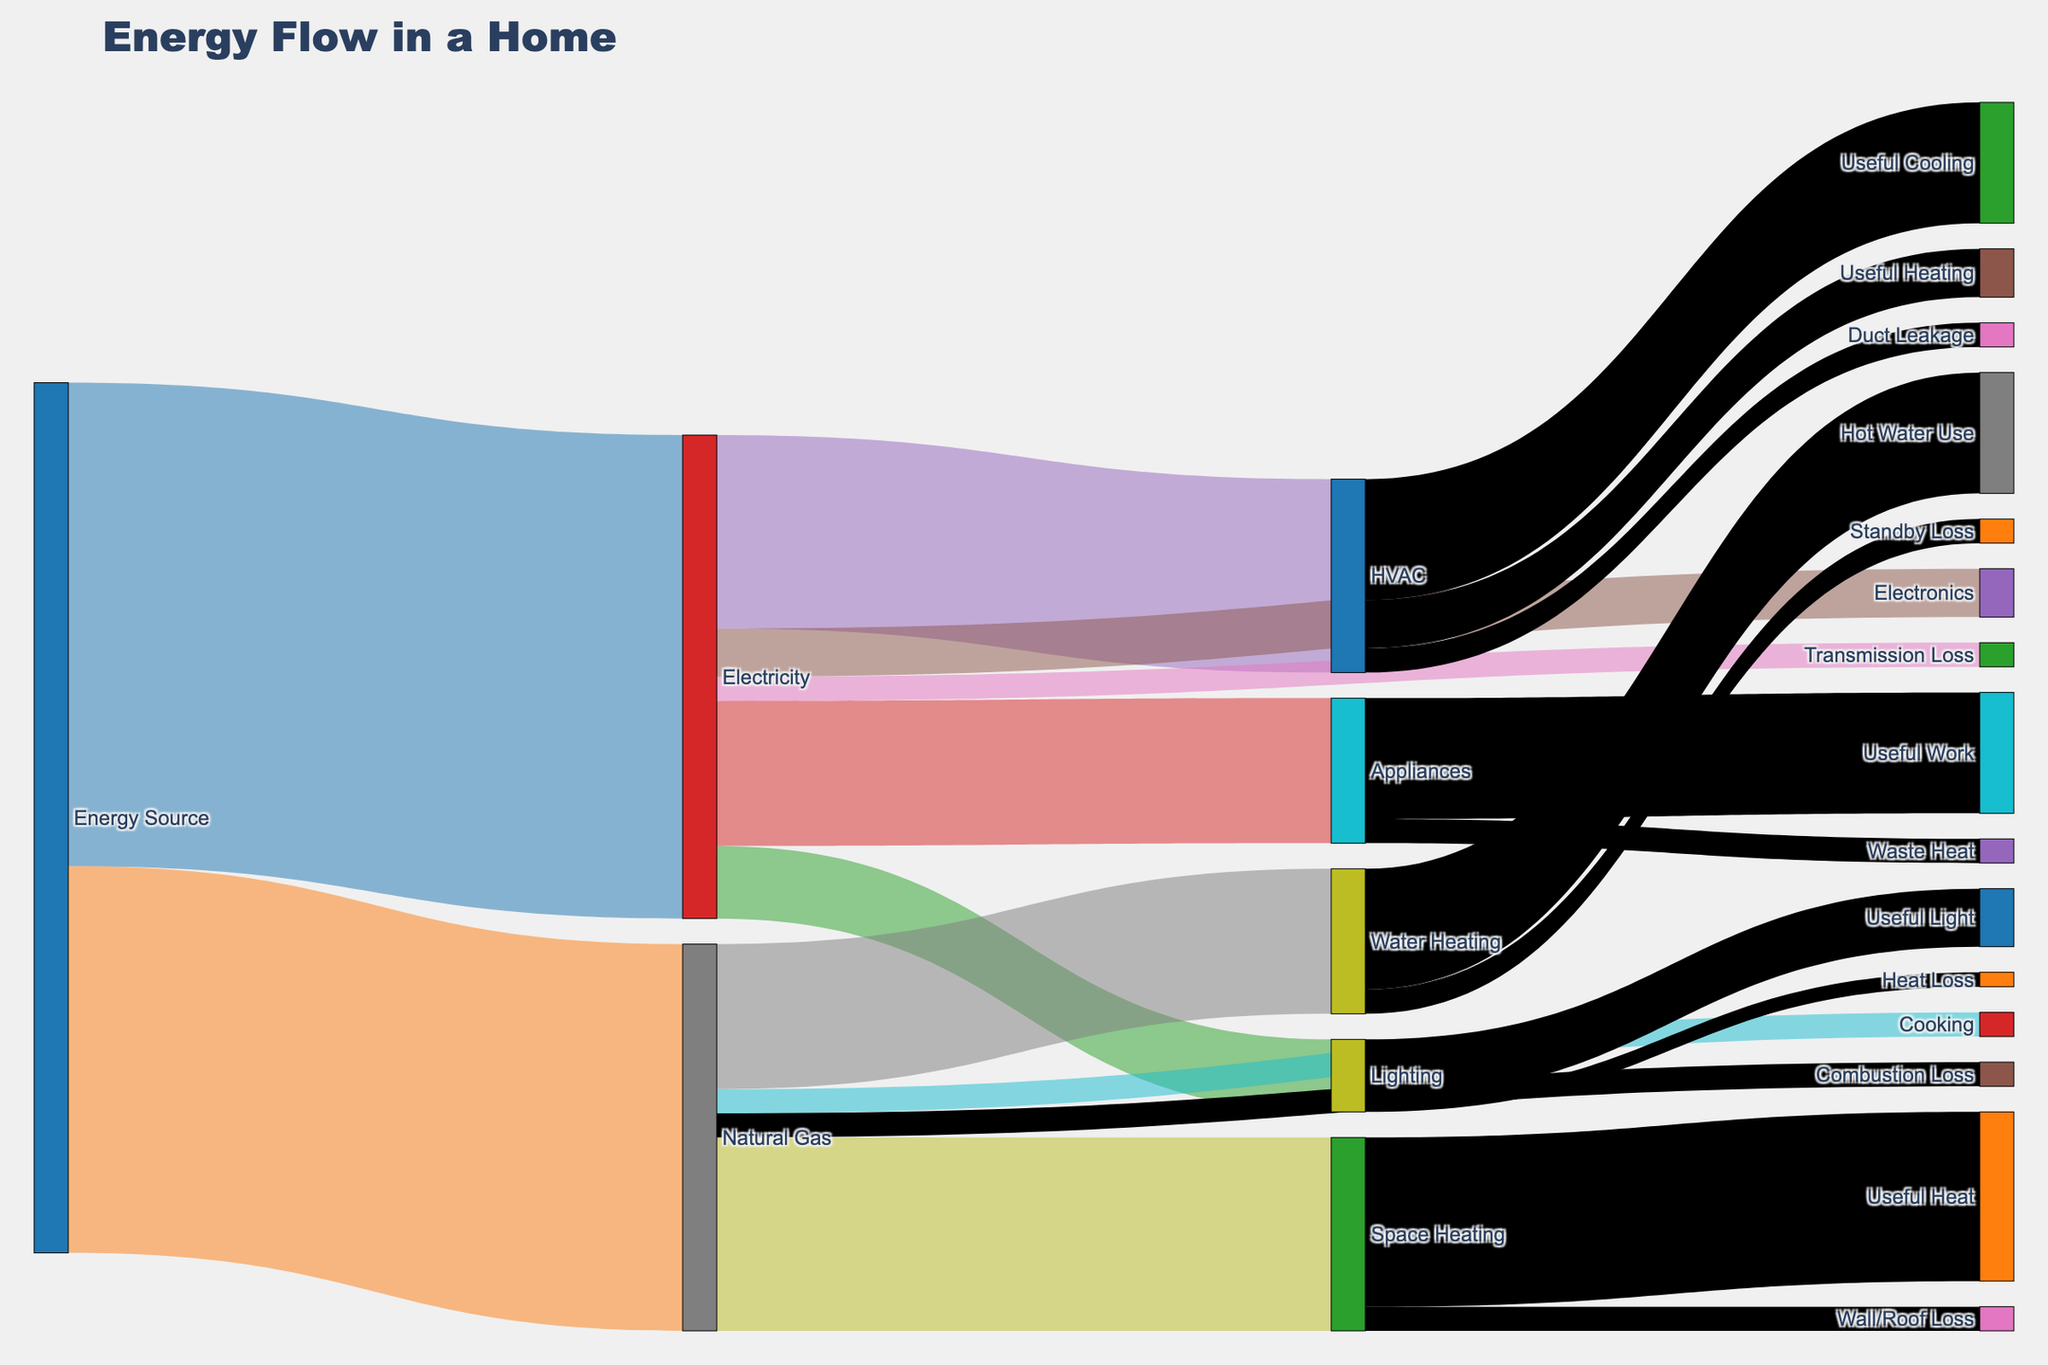What is the main source of energy in the home? The main source of energy can be identified by looking at the values associated with each initial energy source. Electricity has a value of 100, whereas Natural Gas has a value of 80, making Electricity the main source of energy.
Answer: Electricity What is the total amount of energy used for HVAC from both electricity and gas? To find the total amount of energy used for HVAC, we need to add the values from both electricity and natural gas related to HVAC. Electricity provides 40 units of energy to HVAC and Natural Gas is not directly used for HVAC. So, the total is 40.
Answer: 40 How much energy is lost during electricity transmission? The energy lost during electricity transmission is shown as "Transmission Loss" in the diagram. The value associated with this loss is 5.
Answer: 5 Which appliance or usage category receives more energy from electricity, HVAC or Appliances? By comparing the values for HVAC (40) and Appliances (30) in the diagram, it is clear that HVAC receives more energy from electricity than Appliances.
Answer: HVAC How much energy is wasted in the HVAC system through duct leakage? The energy wasted in the HVAC system through duct leakage can be directly seen from the diagram, and it is represented by a value of 5.
Answer: 5 What is the sum of energy used for lighting and electronics from electricity? To determine the total energy used for lighting and electronics, sum the values associated with each from electricity: Lighting (15) and Electronics (10). The sum is 15 + 10 = 25.
Answer: 25 How much energy from natural gas is used for useful heating in space heating? The useful energy for space heating from natural gas is shown in the diagram as "Useful Heat" under Space Heating, with a value of 35.
Answer: 35 What percentage of the total natural gas energy is used for water heating? To find the percentage, divide the energy used for water heating by the total natural gas energy and multiply by 100. The energy used for water heating is 30, and the total natural gas energy is 80. Therefore, (30/80) * 100 = 37.5%.
Answer: 37.5% Which has higher energy use: Appliances from electricity or natural gas for space heating? By comparing the energy values, Appliances use 30 units of electricity and Space Heating uses 40 units of natural gas. Therefore, natural gas for space heating has higher energy use.
Answer: Natural gas for space heating How much total energy is considered wasted due to inefficiencies in the system (including transmission loss, combustion loss, duct leakage, standby loss, waste heat, and heat loss)? The total energy wasted can be calculated by summing all the given inefficient pathways: Transmission Loss (5), Combustion Loss (5), Duct Leakage (5), Standby Loss (5), Waste Heat (5), and Heat Loss (3). Sum = 5 + 5 + 5 + 5 + 5 + 3 = 28.
Answer: 28 